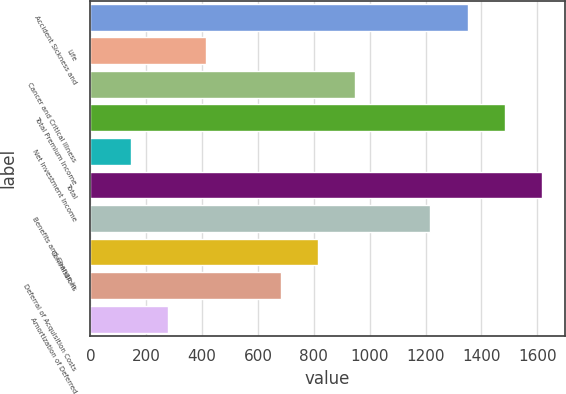Convert chart. <chart><loc_0><loc_0><loc_500><loc_500><bar_chart><fcel>Accident Sickness and<fcel>Life<fcel>Cancer and Critical Illness<fcel>Total Premium Income<fcel>Net Investment Income<fcel>Total<fcel>Benefits and Change in<fcel>Commissions<fcel>Deferral of Acquisition Costs<fcel>Amortization of Deferred<nl><fcel>1350.23<fcel>413.14<fcel>948.62<fcel>1484.1<fcel>145.4<fcel>1617.97<fcel>1216.36<fcel>814.75<fcel>680.88<fcel>279.27<nl></chart> 